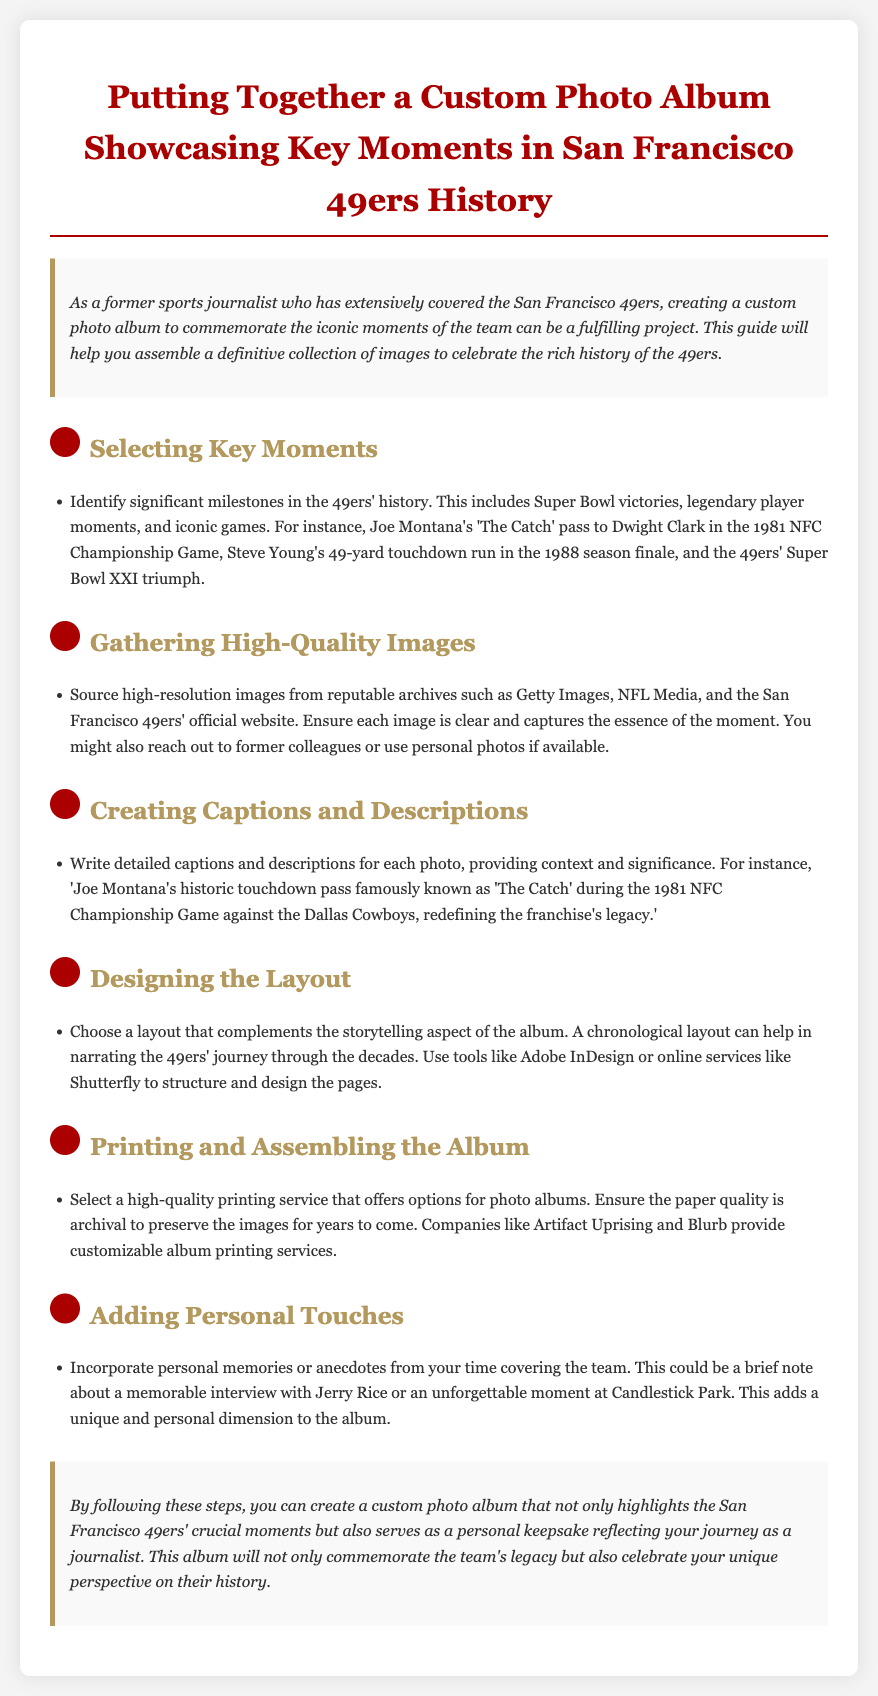What is the title of the guide? The title is prominently displayed at the top of the document, indicating the content's focus on assembling a photo album related to the 49ers.
Answer: Putting Together a Custom Photo Album Showcasing Key Moments in San Francisco 49ers History Which legendary play is mentioned in the assembly instructions? The document specifies iconic moments in the 49ers' history, particularly the famous play involving Joe Montana and Dwight Clark.
Answer: The Catch What layout is recommended for the photo album? The document suggests using a specific type of layout to effectively present the team's history, which aids in storytelling.
Answer: Chronological layout Who are the suggested sources for high-quality images? The guide lists reputable archives where high-resolution images can be obtained for the album.
Answer: Getty Images, NFL Media, and the San Francisco 49ers' official website What aspect should the captions focus on? The document advises on the importance of providing context and significance within the captions associated with the photos.
Answer: Context and significance What is mentioned as a way to add a personal touch? The assembly instructions encourage the inclusion of personal anecdotes or memories tied to the team's history to enrich the album's narrative.
Answer: Personal memories or anecdotes 